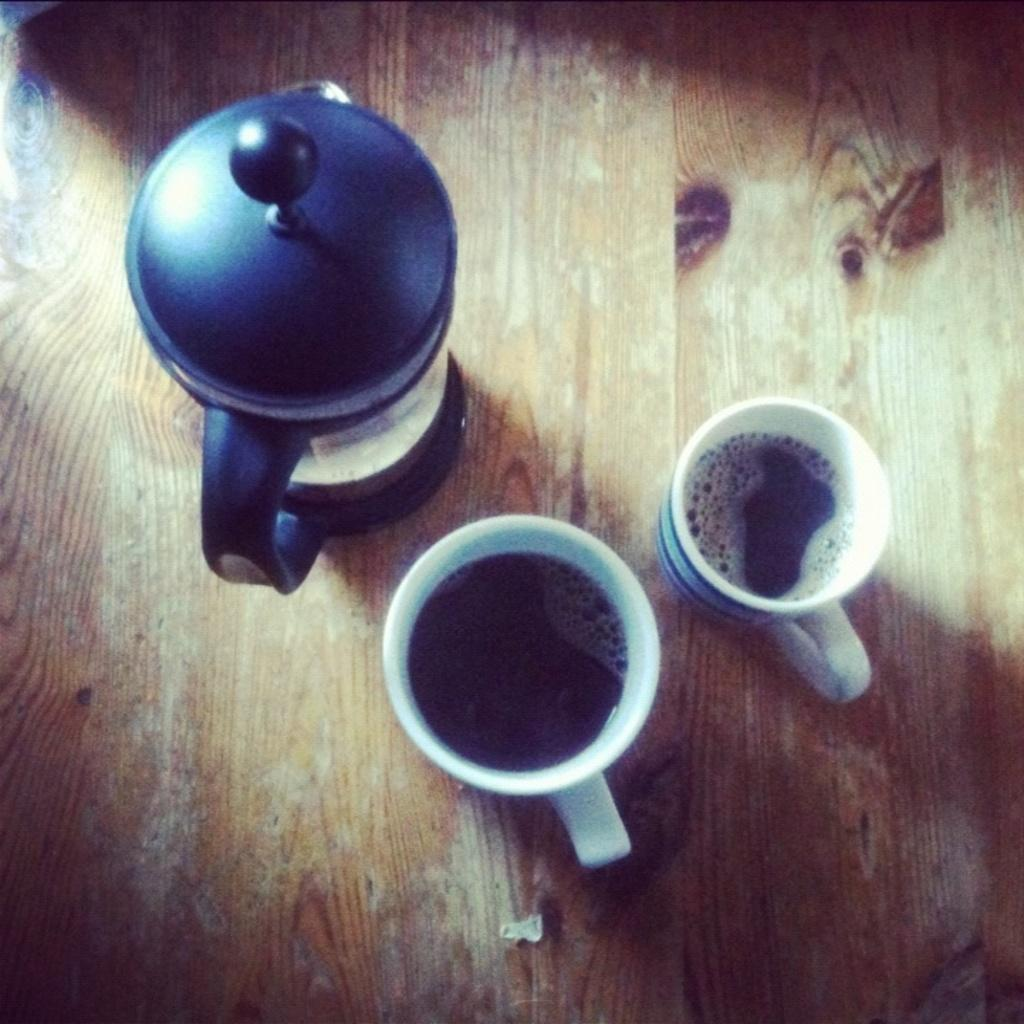How many tea cups are visible in the image? There are two tea cups in the image. What is inside the tea cups? The tea cups contain liquid. What other item related to serving liquid can be seen in the image? There is a water jug in the image. On what surface is the water jug placed? The water jug is on a wooden surface. What type of cheese is being used as fuel for the maid in the image? There is no cheese, fuel, or maid present in the image. 